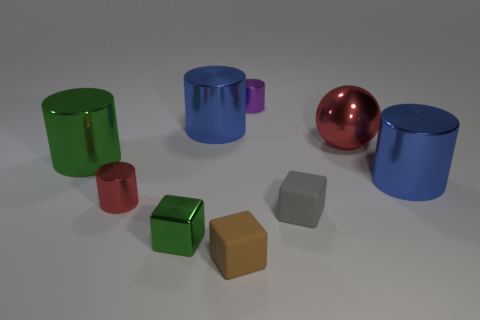What number of things are either large red shiny cylinders or blue things on the left side of the large red metallic thing?
Your response must be concise. 1. Are there more green matte things than tiny purple things?
Give a very brief answer. No. The large blue object that is on the left side of the brown rubber cube has what shape?
Your answer should be very brief. Cylinder. What number of large green objects are the same shape as the big red object?
Provide a succinct answer. 0. What size is the red shiny object that is in front of the green metal thing that is behind the red cylinder?
Offer a very short reply. Small. What number of blue objects are small things or small metallic blocks?
Offer a terse response. 0. Is the number of large blue metal objects that are right of the red metal sphere less than the number of small green cubes behind the red shiny cylinder?
Your answer should be very brief. No. There is a shiny ball; does it have the same size as the blue metallic cylinder that is right of the tiny purple metallic thing?
Your answer should be compact. Yes. How many metal blocks are the same size as the red metal sphere?
Offer a very short reply. 0. How many large things are either purple cylinders or gray rubber blocks?
Make the answer very short. 0. 